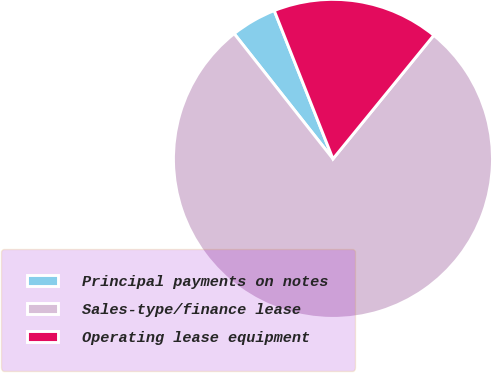<chart> <loc_0><loc_0><loc_500><loc_500><pie_chart><fcel>Principal payments on notes<fcel>Sales-type/finance lease<fcel>Operating lease equipment<nl><fcel>4.63%<fcel>78.47%<fcel>16.89%<nl></chart> 